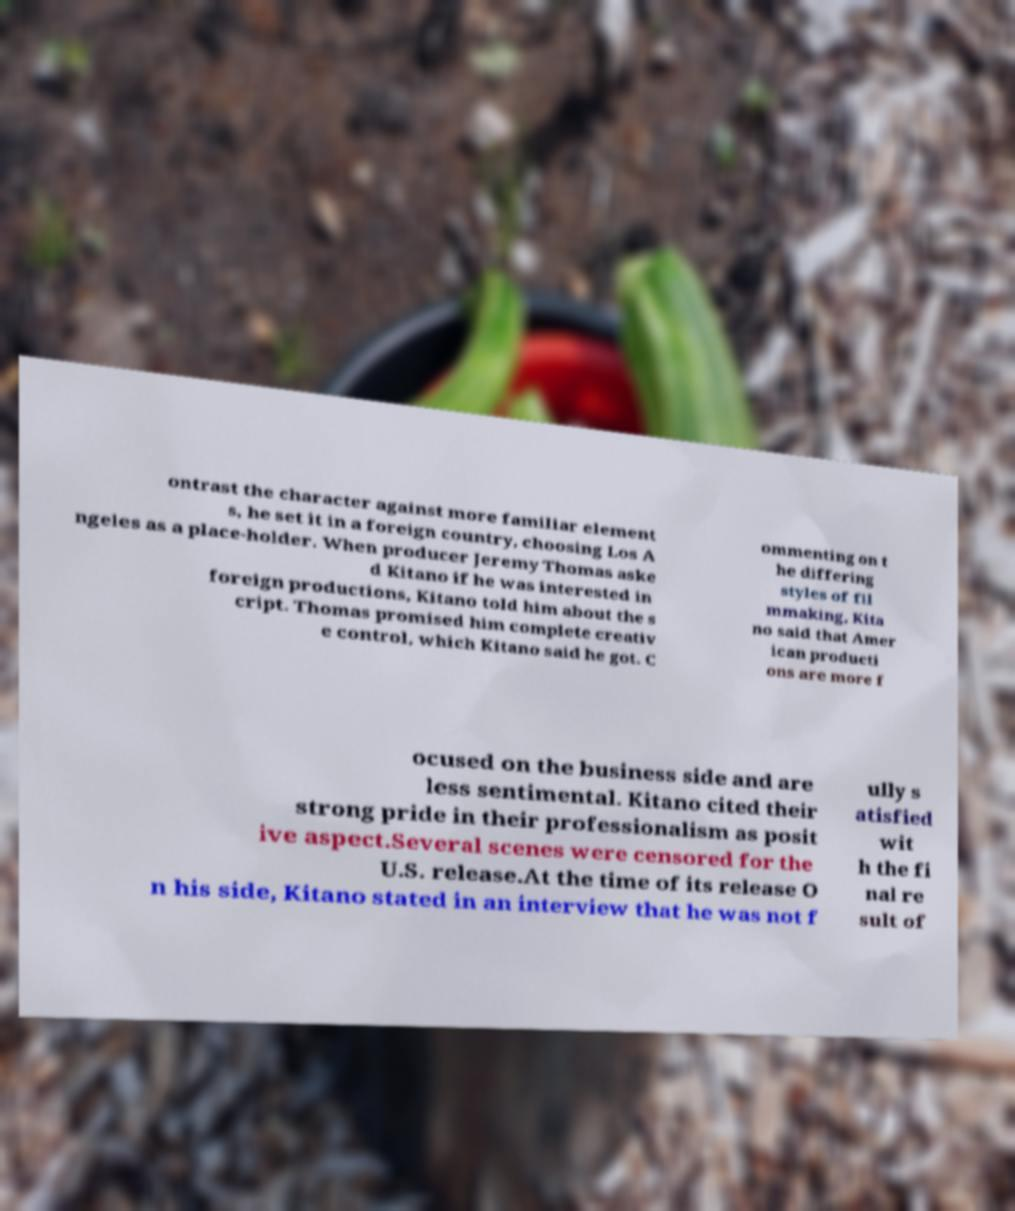Please read and relay the text visible in this image. What does it say? ontrast the character against more familiar element s, he set it in a foreign country, choosing Los A ngeles as a place-holder. When producer Jeremy Thomas aske d Kitano if he was interested in foreign productions, Kitano told him about the s cript. Thomas promised him complete creativ e control, which Kitano said he got. C ommenting on t he differing styles of fil mmaking, Kita no said that Amer ican producti ons are more f ocused on the business side and are less sentimental. Kitano cited their strong pride in their professionalism as posit ive aspect.Several scenes were censored for the U.S. release.At the time of its release O n his side, Kitano stated in an interview that he was not f ully s atisfied wit h the fi nal re sult of 